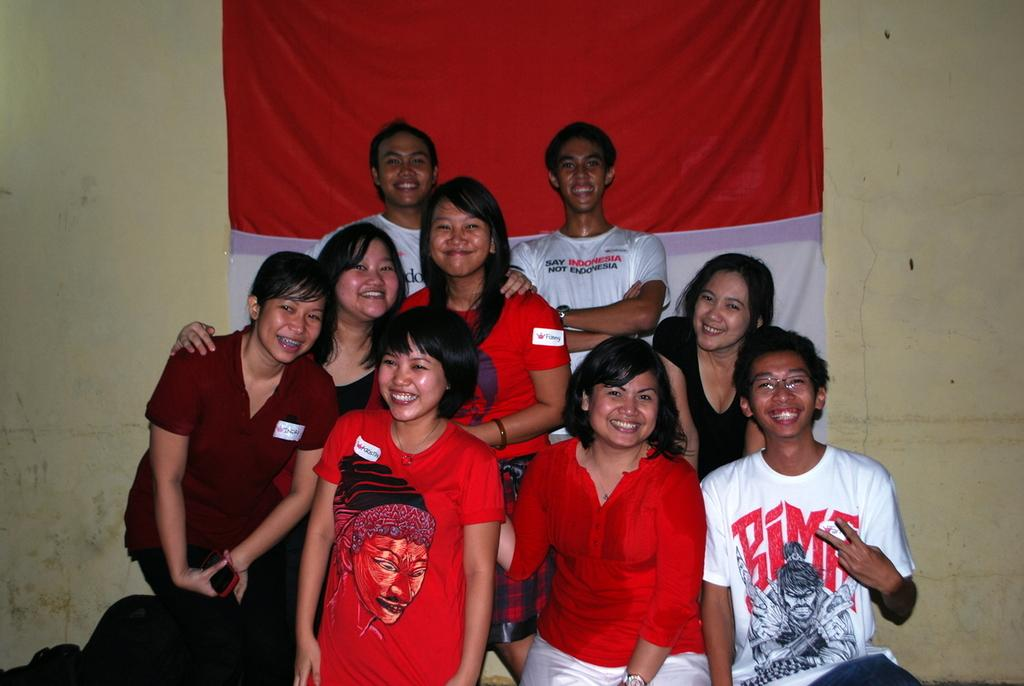How many people are in the image? There is a group of people in the image. What is the facial expression of the people in the image? The people are smiling. What is the woman in the image holding? The woman is holding a mobile. Can you describe any objects present in the image? There are objects present in the image. What can be seen on the wall in the background of the image? There is a cloth on the wall in the background of the image. What type of flower is being used for teaching in the image? There is no flower present in the image, and no teaching activity is depicted. 